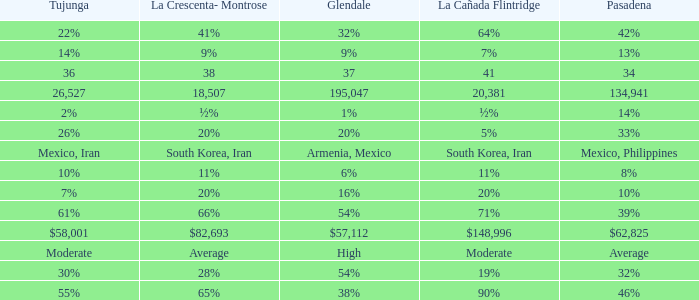What is the figure for La Canada Flintridge when Pasadena is 34? 41.0. 